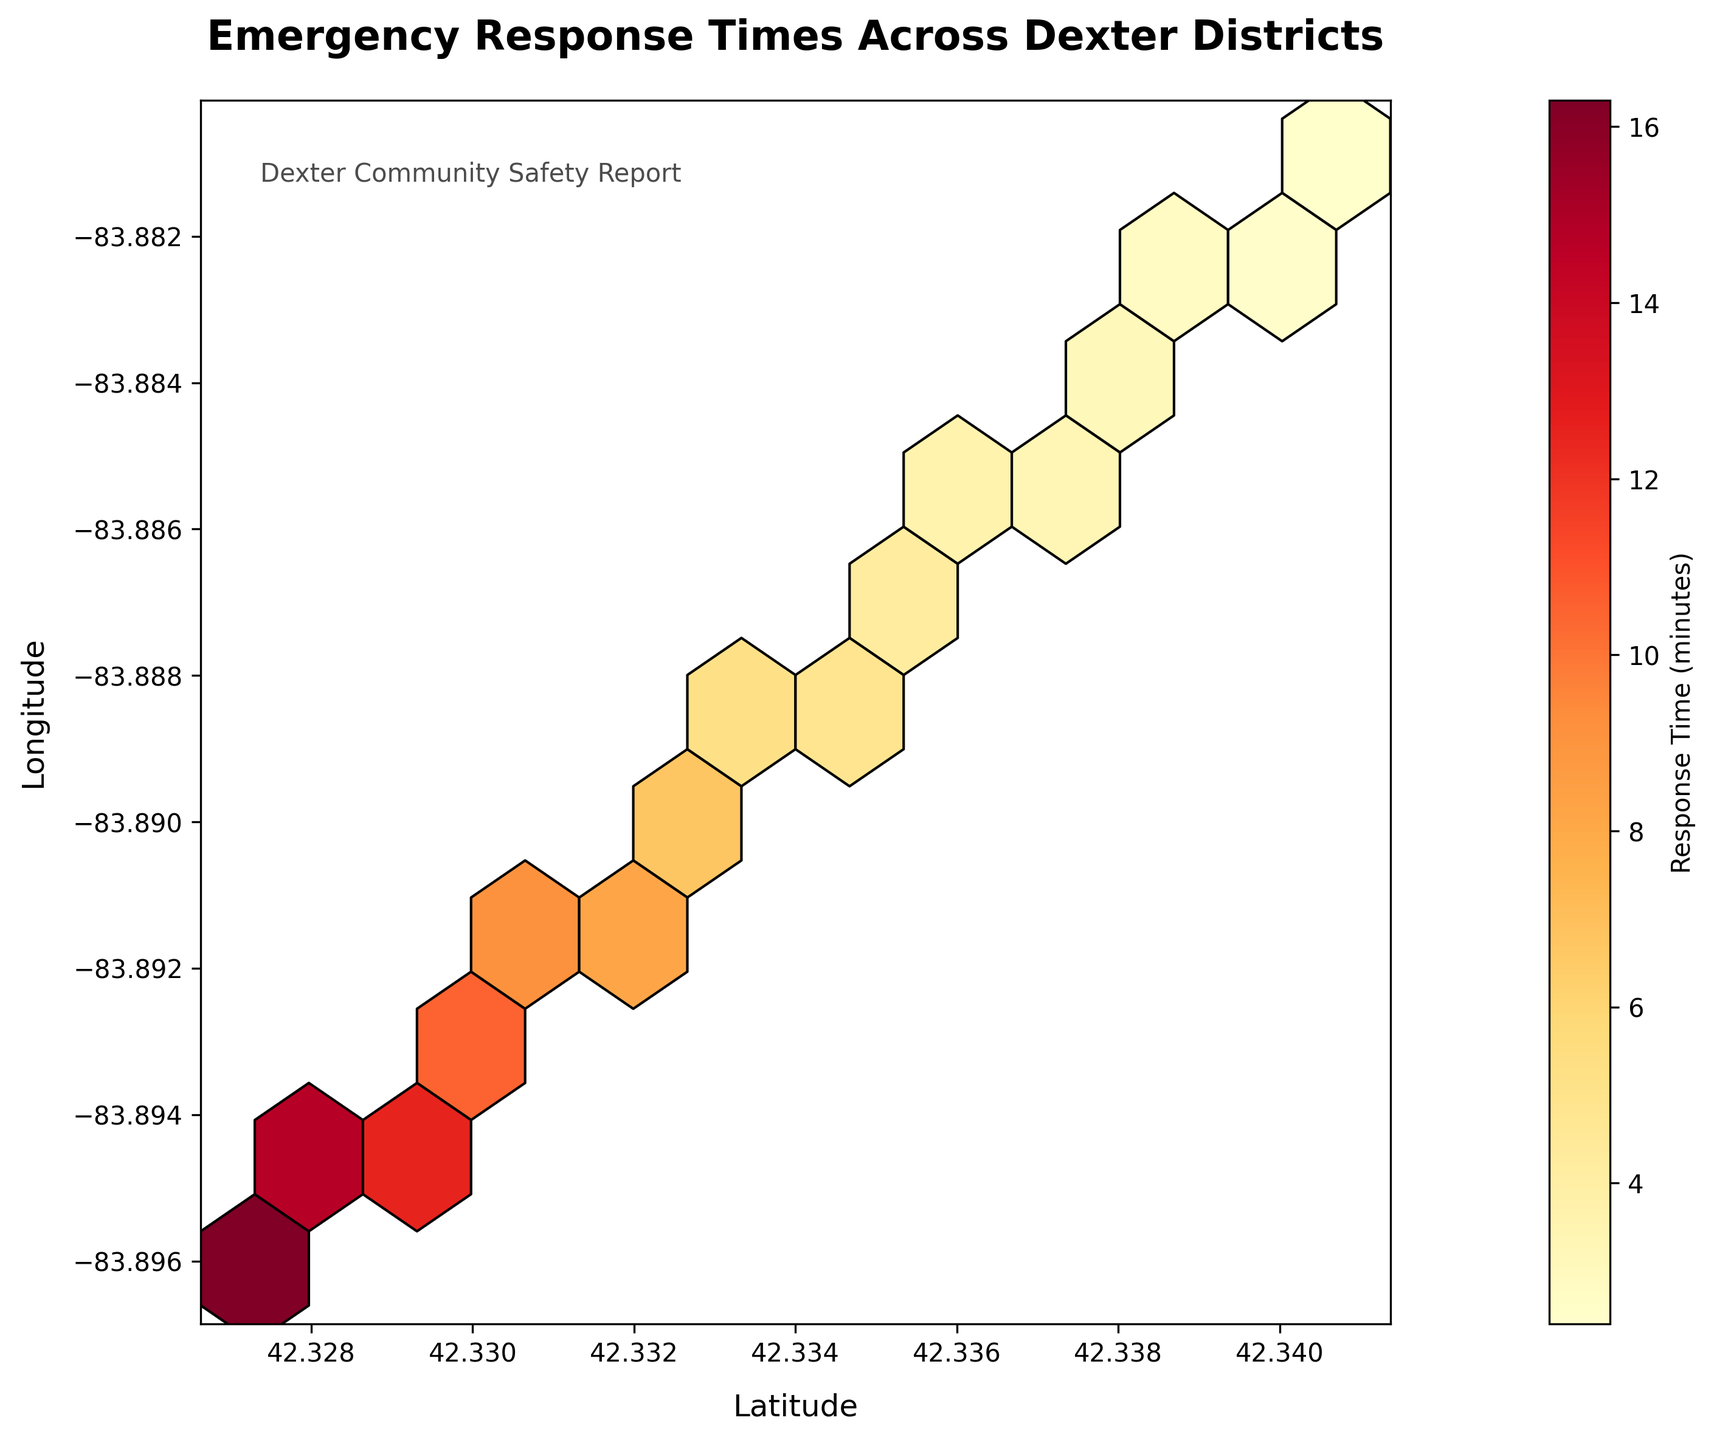What is the title of the figure? The title of the figure is usually placed prominently at the top of the plot. By examining the top center of this figure, we can read the title provided.
Answer: Emergency Response Times Across Dexter Districts What are the labels of the X and Y axes? The labels of the axes explain what each axis represents. In the figure, you can find the X axis labeled as "Latitude" and the Y axis labeled as "Longitude".
Answer: Latitude, Longitude What do the colors represent in this Hexbin plot? In a Hexbin plot, colors indicate a specific variable. Here, by looking at the color bar legend on the right side of the plot, we can see that the colors represent response times in minutes.
Answer: Response times Which district has the shortest emergency response time? By observing the color gradient and identifying the darkest hexbin, which indicates the shortest response time, we can see that the district corresponding to the location (42.3407,-83.8809) has the shortest time.
Answer: (42.3407,-83.8809) Which district has the longest emergency response time? To find the longest response time, look for the lightest color hexbin on the plot. The location corresponding to the marker with the lightest color is (42.3273,-83.8961).
Answer: (42.3273,-83.8961) What is the approximate response time in the district at coordinates (42.3329, -83.8897)? By matching the coordinates on the plot near where the haxbins are located and checking the color, which can be cross-referenced with the color bar, we can estimate the corresponding response time. It appears close to a medium response time zone.
Answer: Approximately 6.1 minutes Is there a noticeable trend in emergency response times across the districts based on this plot? From the Hexbin plot, the darker areas (shorter response times) are concentrated in the northern regions, while the lighter areas (longer response times) are towards the southern regions, indicating a trend from north to south.
Answer: Yes, a trend from shorter in the north to longer in the south Which area shows a significant concentration of lower emergency response times? By examining the clusters of darker colors, which signify lower response times, we can see a clear concentration around the northern coordinates of the hexbin plot.
Answer: Northern districts How does the response time change as you move from (42.3407, -83.8809) to (42.3273, -83.8961)? Moving from the point with the shortest response time to the one with the longest, a transition from darker to lighter shades of color can be observed, indicating an increase in response time.
Answer: Increases What is the color of the hexbin representing the longest response time, and what does it indicate about the emergency response situation in that district? By looking at the lightest color hexbin, we find it is a very light shade, which is explained by the color bar as indicating longer response times. This suggests that the emergency response situation is less efficient in that district.
Answer: Very light shade, indicating longer response times 